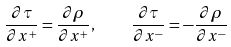Convert formula to latex. <formula><loc_0><loc_0><loc_500><loc_500>\frac { \partial \tau } { \partial x ^ { + } } = \frac { \partial \rho } { \partial x ^ { + } } , \quad \frac { \partial \tau } { \partial x ^ { - } } = - \frac { \partial \rho } { \partial x ^ { - } }</formula> 